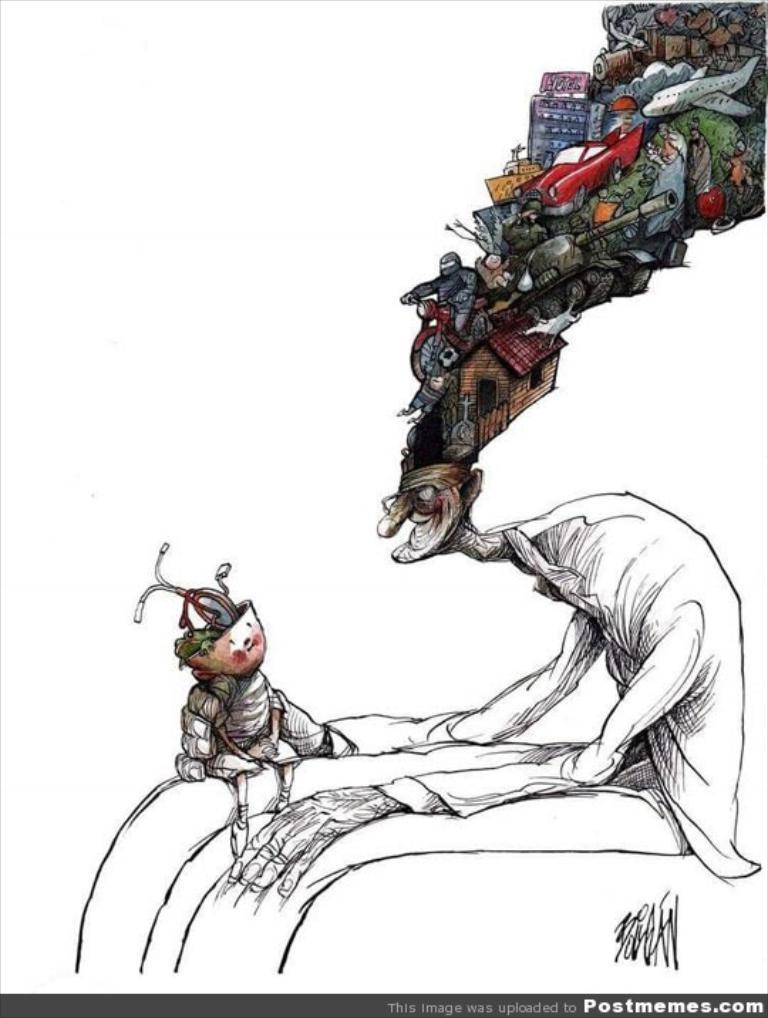What type of artwork is depicted in the image? The image is a painting. What is the main subject of the painting? There is a person holding a kid in the painting. Is there any text present in the painting? Yes, there is text at the bottom of the painting. What type of wound is visible on the carpenter's hand in the painting? There is no carpenter or wound present in the painting; it features a person holding a kid and text at the bottom. What is the plot of the story being told in the painting? The painting is not a story with a plot; it is a visual representation of a person holding a kid. 